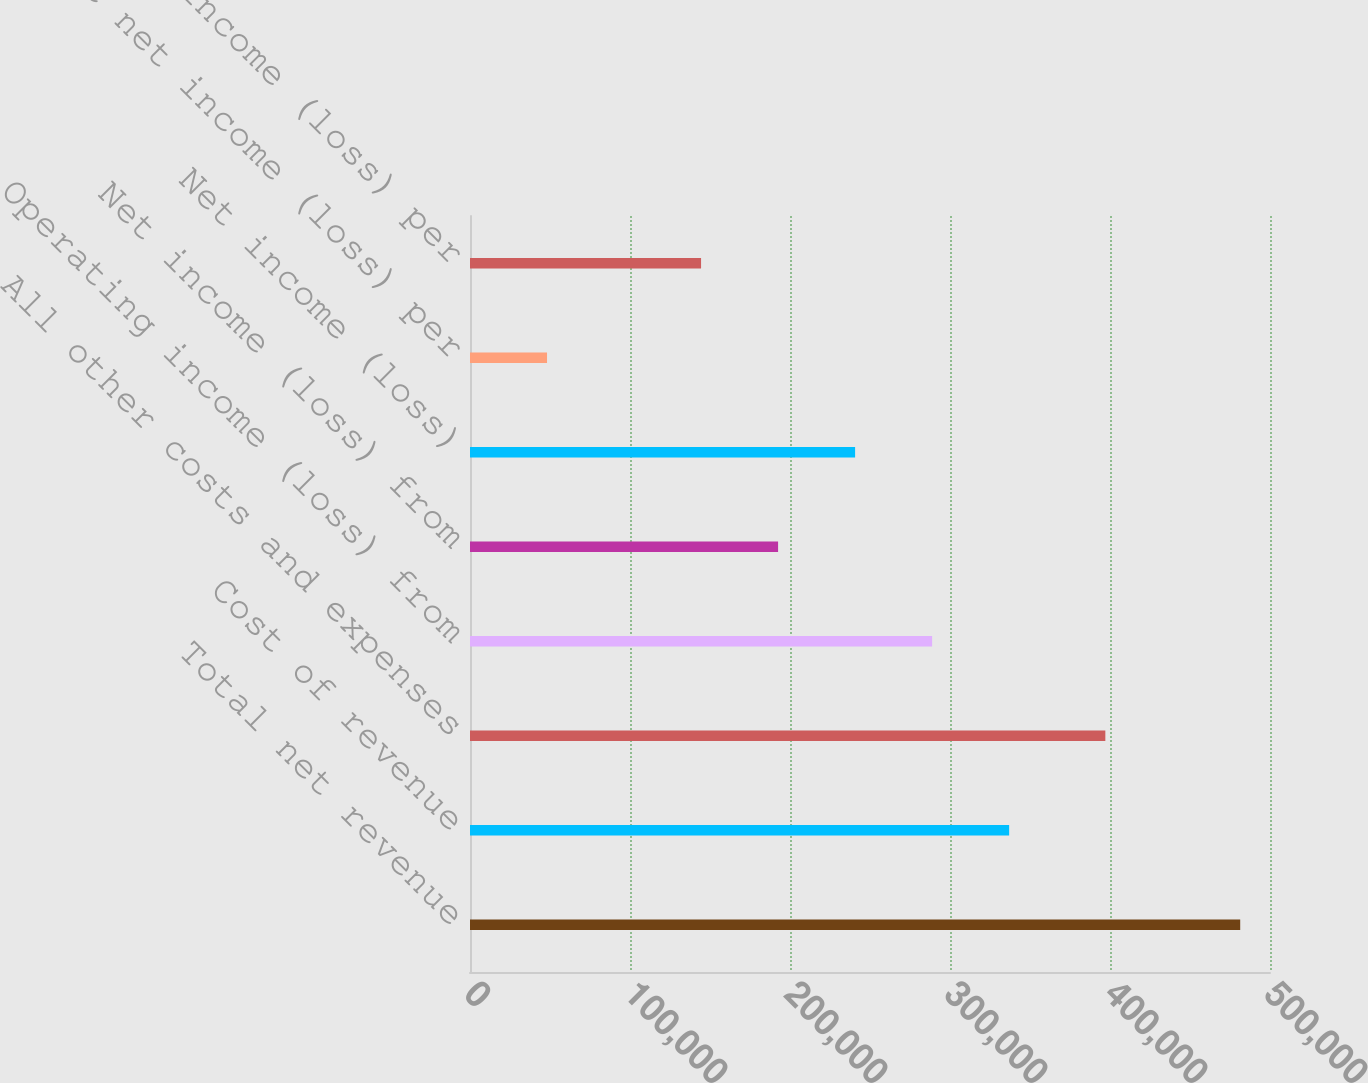Convert chart to OTSL. <chart><loc_0><loc_0><loc_500><loc_500><bar_chart><fcel>Total net revenue<fcel>Cost of revenue<fcel>All other costs and expenses<fcel>Operating income (loss) from<fcel>Net income (loss) from<fcel>Net income (loss)<fcel>Basic net income (loss) per<fcel>Diluted net income (loss) per<nl><fcel>481379<fcel>336965<fcel>397088<fcel>288827<fcel>192552<fcel>240690<fcel>48138<fcel>144414<nl></chart> 